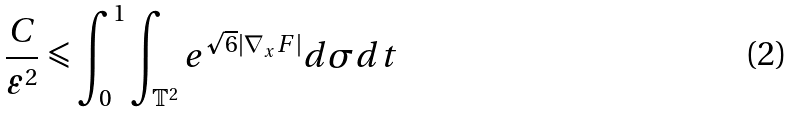<formula> <loc_0><loc_0><loc_500><loc_500>\frac { C } { \varepsilon ^ { 2 } } \leqslant \int _ { 0 } ^ { 1 } \int _ { \mathbb { T } ^ { 2 } } e ^ { \sqrt { 6 } | \nabla _ { x } F | } d \sigma d t</formula> 